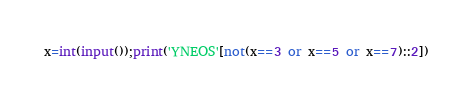<code> <loc_0><loc_0><loc_500><loc_500><_Python_>x=int(input());print('YNEOS'[not(x==3 or x==5 or x==7)::2])</code> 